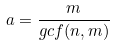Convert formula to latex. <formula><loc_0><loc_0><loc_500><loc_500>a = \frac { m } { g c f ( n , m ) }</formula> 